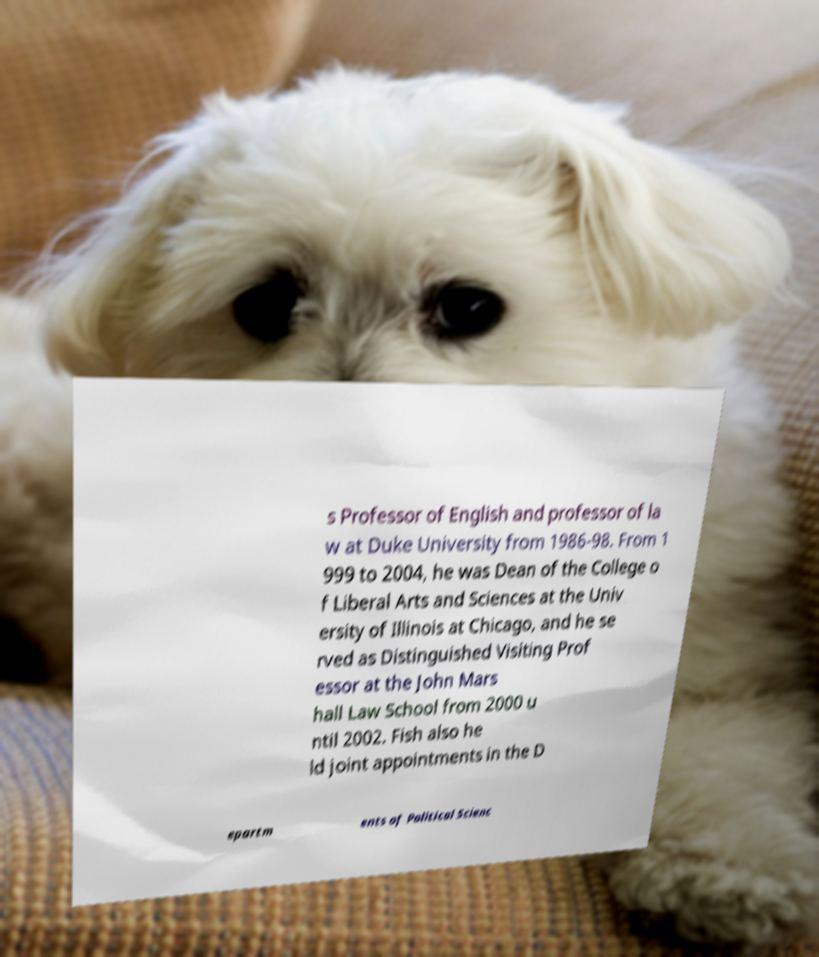For documentation purposes, I need the text within this image transcribed. Could you provide that? s Professor of English and professor of la w at Duke University from 1986-98. From 1 999 to 2004, he was Dean of the College o f Liberal Arts and Sciences at the Univ ersity of Illinois at Chicago, and he se rved as Distinguished Visiting Prof essor at the John Mars hall Law School from 2000 u ntil 2002. Fish also he ld joint appointments in the D epartm ents of Political Scienc 